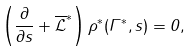<formula> <loc_0><loc_0><loc_500><loc_500>\left ( \frac { \partial } { \partial s } + \overline { \mathcal { L } } ^ { \ast } \right ) \rho ^ { \ast } ( \Gamma ^ { \ast } , s ) = 0 ,</formula> 